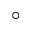<formula> <loc_0><loc_0><loc_500><loc_500>^ { \circ }</formula> 